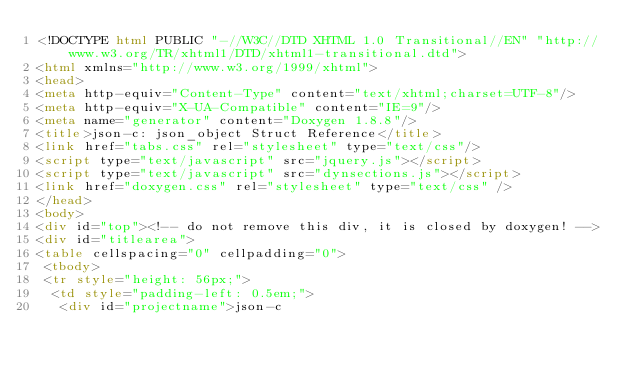<code> <loc_0><loc_0><loc_500><loc_500><_HTML_><!DOCTYPE html PUBLIC "-//W3C//DTD XHTML 1.0 Transitional//EN" "http://www.w3.org/TR/xhtml1/DTD/xhtml1-transitional.dtd">
<html xmlns="http://www.w3.org/1999/xhtml">
<head>
<meta http-equiv="Content-Type" content="text/xhtml;charset=UTF-8"/>
<meta http-equiv="X-UA-Compatible" content="IE=9"/>
<meta name="generator" content="Doxygen 1.8.8"/>
<title>json-c: json_object Struct Reference</title>
<link href="tabs.css" rel="stylesheet" type="text/css"/>
<script type="text/javascript" src="jquery.js"></script>
<script type="text/javascript" src="dynsections.js"></script>
<link href="doxygen.css" rel="stylesheet" type="text/css" />
</head>
<body>
<div id="top"><!-- do not remove this div, it is closed by doxygen! -->
<div id="titlearea">
<table cellspacing="0" cellpadding="0">
 <tbody>
 <tr style="height: 56px;">
  <td style="padding-left: 0.5em;">
   <div id="projectname">json-c</code> 